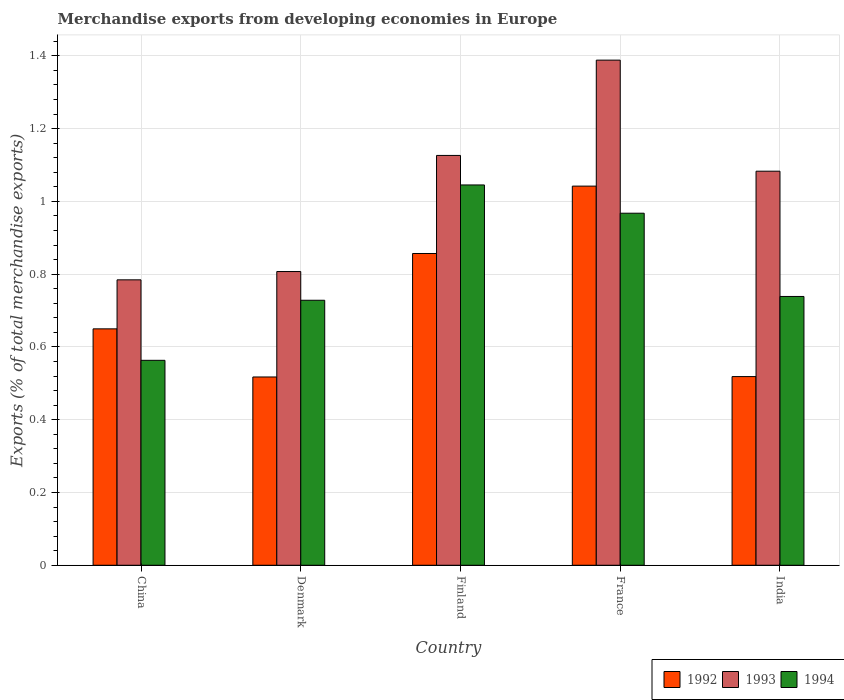How many different coloured bars are there?
Make the answer very short. 3. How many groups of bars are there?
Ensure brevity in your answer.  5. What is the percentage of total merchandise exports in 1992 in India?
Provide a short and direct response. 0.52. Across all countries, what is the maximum percentage of total merchandise exports in 1994?
Your answer should be compact. 1.05. Across all countries, what is the minimum percentage of total merchandise exports in 1993?
Keep it short and to the point. 0.78. In which country was the percentage of total merchandise exports in 1994 maximum?
Provide a succinct answer. Finland. What is the total percentage of total merchandise exports in 1993 in the graph?
Make the answer very short. 5.19. What is the difference between the percentage of total merchandise exports in 1994 in China and that in France?
Make the answer very short. -0.4. What is the difference between the percentage of total merchandise exports in 1992 in China and the percentage of total merchandise exports in 1993 in India?
Provide a succinct answer. -0.43. What is the average percentage of total merchandise exports in 1992 per country?
Your answer should be compact. 0.72. What is the difference between the percentage of total merchandise exports of/in 1994 and percentage of total merchandise exports of/in 1992 in India?
Give a very brief answer. 0.22. In how many countries, is the percentage of total merchandise exports in 1994 greater than 1.2400000000000002 %?
Your response must be concise. 0. What is the ratio of the percentage of total merchandise exports in 1994 in Denmark to that in France?
Keep it short and to the point. 0.75. What is the difference between the highest and the second highest percentage of total merchandise exports in 1992?
Keep it short and to the point. -0.19. What is the difference between the highest and the lowest percentage of total merchandise exports in 1992?
Offer a very short reply. 0.52. Is the sum of the percentage of total merchandise exports in 1993 in Denmark and Finland greater than the maximum percentage of total merchandise exports in 1994 across all countries?
Your answer should be compact. Yes. What does the 2nd bar from the right in France represents?
Provide a short and direct response. 1993. Are all the bars in the graph horizontal?
Your answer should be compact. No. Are the values on the major ticks of Y-axis written in scientific E-notation?
Your answer should be very brief. No. Does the graph contain any zero values?
Make the answer very short. No. Does the graph contain grids?
Your response must be concise. Yes. How many legend labels are there?
Your answer should be very brief. 3. What is the title of the graph?
Ensure brevity in your answer.  Merchandise exports from developing economies in Europe. What is the label or title of the Y-axis?
Make the answer very short. Exports (% of total merchandise exports). What is the Exports (% of total merchandise exports) in 1992 in China?
Ensure brevity in your answer.  0.65. What is the Exports (% of total merchandise exports) of 1993 in China?
Offer a terse response. 0.78. What is the Exports (% of total merchandise exports) of 1994 in China?
Give a very brief answer. 0.56. What is the Exports (% of total merchandise exports) in 1992 in Denmark?
Ensure brevity in your answer.  0.52. What is the Exports (% of total merchandise exports) of 1993 in Denmark?
Offer a very short reply. 0.81. What is the Exports (% of total merchandise exports) of 1994 in Denmark?
Ensure brevity in your answer.  0.73. What is the Exports (% of total merchandise exports) in 1992 in Finland?
Your answer should be very brief. 0.86. What is the Exports (% of total merchandise exports) in 1993 in Finland?
Make the answer very short. 1.13. What is the Exports (% of total merchandise exports) in 1994 in Finland?
Your answer should be very brief. 1.05. What is the Exports (% of total merchandise exports) of 1992 in France?
Make the answer very short. 1.04. What is the Exports (% of total merchandise exports) of 1993 in France?
Keep it short and to the point. 1.39. What is the Exports (% of total merchandise exports) of 1994 in France?
Give a very brief answer. 0.97. What is the Exports (% of total merchandise exports) of 1992 in India?
Give a very brief answer. 0.52. What is the Exports (% of total merchandise exports) of 1993 in India?
Make the answer very short. 1.08. What is the Exports (% of total merchandise exports) of 1994 in India?
Your answer should be compact. 0.74. Across all countries, what is the maximum Exports (% of total merchandise exports) in 1992?
Ensure brevity in your answer.  1.04. Across all countries, what is the maximum Exports (% of total merchandise exports) of 1993?
Ensure brevity in your answer.  1.39. Across all countries, what is the maximum Exports (% of total merchandise exports) in 1994?
Offer a terse response. 1.05. Across all countries, what is the minimum Exports (% of total merchandise exports) of 1992?
Keep it short and to the point. 0.52. Across all countries, what is the minimum Exports (% of total merchandise exports) of 1993?
Offer a very short reply. 0.78. Across all countries, what is the minimum Exports (% of total merchandise exports) in 1994?
Offer a terse response. 0.56. What is the total Exports (% of total merchandise exports) in 1992 in the graph?
Your answer should be very brief. 3.58. What is the total Exports (% of total merchandise exports) in 1993 in the graph?
Your answer should be very brief. 5.19. What is the total Exports (% of total merchandise exports) of 1994 in the graph?
Make the answer very short. 4.04. What is the difference between the Exports (% of total merchandise exports) of 1992 in China and that in Denmark?
Provide a succinct answer. 0.13. What is the difference between the Exports (% of total merchandise exports) of 1993 in China and that in Denmark?
Your response must be concise. -0.02. What is the difference between the Exports (% of total merchandise exports) of 1994 in China and that in Denmark?
Provide a succinct answer. -0.17. What is the difference between the Exports (% of total merchandise exports) of 1992 in China and that in Finland?
Provide a succinct answer. -0.21. What is the difference between the Exports (% of total merchandise exports) in 1993 in China and that in Finland?
Ensure brevity in your answer.  -0.34. What is the difference between the Exports (% of total merchandise exports) of 1994 in China and that in Finland?
Make the answer very short. -0.48. What is the difference between the Exports (% of total merchandise exports) in 1992 in China and that in France?
Your response must be concise. -0.39. What is the difference between the Exports (% of total merchandise exports) of 1993 in China and that in France?
Your response must be concise. -0.6. What is the difference between the Exports (% of total merchandise exports) in 1994 in China and that in France?
Offer a terse response. -0.4. What is the difference between the Exports (% of total merchandise exports) in 1992 in China and that in India?
Keep it short and to the point. 0.13. What is the difference between the Exports (% of total merchandise exports) of 1993 in China and that in India?
Provide a succinct answer. -0.3. What is the difference between the Exports (% of total merchandise exports) in 1994 in China and that in India?
Provide a succinct answer. -0.18. What is the difference between the Exports (% of total merchandise exports) of 1992 in Denmark and that in Finland?
Offer a terse response. -0.34. What is the difference between the Exports (% of total merchandise exports) in 1993 in Denmark and that in Finland?
Your answer should be compact. -0.32. What is the difference between the Exports (% of total merchandise exports) in 1994 in Denmark and that in Finland?
Your response must be concise. -0.32. What is the difference between the Exports (% of total merchandise exports) in 1992 in Denmark and that in France?
Offer a terse response. -0.52. What is the difference between the Exports (% of total merchandise exports) in 1993 in Denmark and that in France?
Ensure brevity in your answer.  -0.58. What is the difference between the Exports (% of total merchandise exports) in 1994 in Denmark and that in France?
Offer a terse response. -0.24. What is the difference between the Exports (% of total merchandise exports) in 1992 in Denmark and that in India?
Provide a succinct answer. -0. What is the difference between the Exports (% of total merchandise exports) in 1993 in Denmark and that in India?
Offer a terse response. -0.28. What is the difference between the Exports (% of total merchandise exports) of 1994 in Denmark and that in India?
Make the answer very short. -0.01. What is the difference between the Exports (% of total merchandise exports) in 1992 in Finland and that in France?
Your response must be concise. -0.19. What is the difference between the Exports (% of total merchandise exports) of 1993 in Finland and that in France?
Your answer should be very brief. -0.26. What is the difference between the Exports (% of total merchandise exports) in 1994 in Finland and that in France?
Make the answer very short. 0.08. What is the difference between the Exports (% of total merchandise exports) of 1992 in Finland and that in India?
Your answer should be compact. 0.34. What is the difference between the Exports (% of total merchandise exports) in 1993 in Finland and that in India?
Provide a succinct answer. 0.04. What is the difference between the Exports (% of total merchandise exports) in 1994 in Finland and that in India?
Give a very brief answer. 0.31. What is the difference between the Exports (% of total merchandise exports) of 1992 in France and that in India?
Your answer should be very brief. 0.52. What is the difference between the Exports (% of total merchandise exports) in 1993 in France and that in India?
Offer a very short reply. 0.31. What is the difference between the Exports (% of total merchandise exports) of 1994 in France and that in India?
Your answer should be very brief. 0.23. What is the difference between the Exports (% of total merchandise exports) of 1992 in China and the Exports (% of total merchandise exports) of 1993 in Denmark?
Provide a succinct answer. -0.16. What is the difference between the Exports (% of total merchandise exports) in 1992 in China and the Exports (% of total merchandise exports) in 1994 in Denmark?
Offer a terse response. -0.08. What is the difference between the Exports (% of total merchandise exports) in 1993 in China and the Exports (% of total merchandise exports) in 1994 in Denmark?
Your response must be concise. 0.06. What is the difference between the Exports (% of total merchandise exports) of 1992 in China and the Exports (% of total merchandise exports) of 1993 in Finland?
Your response must be concise. -0.48. What is the difference between the Exports (% of total merchandise exports) in 1992 in China and the Exports (% of total merchandise exports) in 1994 in Finland?
Offer a terse response. -0.4. What is the difference between the Exports (% of total merchandise exports) of 1993 in China and the Exports (% of total merchandise exports) of 1994 in Finland?
Provide a succinct answer. -0.26. What is the difference between the Exports (% of total merchandise exports) in 1992 in China and the Exports (% of total merchandise exports) in 1993 in France?
Keep it short and to the point. -0.74. What is the difference between the Exports (% of total merchandise exports) in 1992 in China and the Exports (% of total merchandise exports) in 1994 in France?
Offer a very short reply. -0.32. What is the difference between the Exports (% of total merchandise exports) of 1993 in China and the Exports (% of total merchandise exports) of 1994 in France?
Provide a short and direct response. -0.18. What is the difference between the Exports (% of total merchandise exports) of 1992 in China and the Exports (% of total merchandise exports) of 1993 in India?
Your answer should be very brief. -0.43. What is the difference between the Exports (% of total merchandise exports) in 1992 in China and the Exports (% of total merchandise exports) in 1994 in India?
Your response must be concise. -0.09. What is the difference between the Exports (% of total merchandise exports) of 1993 in China and the Exports (% of total merchandise exports) of 1994 in India?
Give a very brief answer. 0.05. What is the difference between the Exports (% of total merchandise exports) of 1992 in Denmark and the Exports (% of total merchandise exports) of 1993 in Finland?
Ensure brevity in your answer.  -0.61. What is the difference between the Exports (% of total merchandise exports) in 1992 in Denmark and the Exports (% of total merchandise exports) in 1994 in Finland?
Make the answer very short. -0.53. What is the difference between the Exports (% of total merchandise exports) of 1993 in Denmark and the Exports (% of total merchandise exports) of 1994 in Finland?
Give a very brief answer. -0.24. What is the difference between the Exports (% of total merchandise exports) of 1992 in Denmark and the Exports (% of total merchandise exports) of 1993 in France?
Make the answer very short. -0.87. What is the difference between the Exports (% of total merchandise exports) of 1992 in Denmark and the Exports (% of total merchandise exports) of 1994 in France?
Your answer should be very brief. -0.45. What is the difference between the Exports (% of total merchandise exports) of 1993 in Denmark and the Exports (% of total merchandise exports) of 1994 in France?
Your answer should be very brief. -0.16. What is the difference between the Exports (% of total merchandise exports) of 1992 in Denmark and the Exports (% of total merchandise exports) of 1993 in India?
Ensure brevity in your answer.  -0.57. What is the difference between the Exports (% of total merchandise exports) in 1992 in Denmark and the Exports (% of total merchandise exports) in 1994 in India?
Keep it short and to the point. -0.22. What is the difference between the Exports (% of total merchandise exports) in 1993 in Denmark and the Exports (% of total merchandise exports) in 1994 in India?
Provide a succinct answer. 0.07. What is the difference between the Exports (% of total merchandise exports) in 1992 in Finland and the Exports (% of total merchandise exports) in 1993 in France?
Keep it short and to the point. -0.53. What is the difference between the Exports (% of total merchandise exports) of 1992 in Finland and the Exports (% of total merchandise exports) of 1994 in France?
Ensure brevity in your answer.  -0.11. What is the difference between the Exports (% of total merchandise exports) in 1993 in Finland and the Exports (% of total merchandise exports) in 1994 in France?
Your response must be concise. 0.16. What is the difference between the Exports (% of total merchandise exports) of 1992 in Finland and the Exports (% of total merchandise exports) of 1993 in India?
Provide a succinct answer. -0.23. What is the difference between the Exports (% of total merchandise exports) of 1992 in Finland and the Exports (% of total merchandise exports) of 1994 in India?
Make the answer very short. 0.12. What is the difference between the Exports (% of total merchandise exports) of 1993 in Finland and the Exports (% of total merchandise exports) of 1994 in India?
Give a very brief answer. 0.39. What is the difference between the Exports (% of total merchandise exports) of 1992 in France and the Exports (% of total merchandise exports) of 1993 in India?
Your answer should be compact. -0.04. What is the difference between the Exports (% of total merchandise exports) in 1992 in France and the Exports (% of total merchandise exports) in 1994 in India?
Ensure brevity in your answer.  0.3. What is the difference between the Exports (% of total merchandise exports) in 1993 in France and the Exports (% of total merchandise exports) in 1994 in India?
Provide a short and direct response. 0.65. What is the average Exports (% of total merchandise exports) in 1992 per country?
Keep it short and to the point. 0.72. What is the average Exports (% of total merchandise exports) of 1993 per country?
Make the answer very short. 1.04. What is the average Exports (% of total merchandise exports) in 1994 per country?
Offer a terse response. 0.81. What is the difference between the Exports (% of total merchandise exports) in 1992 and Exports (% of total merchandise exports) in 1993 in China?
Ensure brevity in your answer.  -0.13. What is the difference between the Exports (% of total merchandise exports) in 1992 and Exports (% of total merchandise exports) in 1994 in China?
Offer a very short reply. 0.09. What is the difference between the Exports (% of total merchandise exports) in 1993 and Exports (% of total merchandise exports) in 1994 in China?
Your answer should be compact. 0.22. What is the difference between the Exports (% of total merchandise exports) in 1992 and Exports (% of total merchandise exports) in 1993 in Denmark?
Ensure brevity in your answer.  -0.29. What is the difference between the Exports (% of total merchandise exports) of 1992 and Exports (% of total merchandise exports) of 1994 in Denmark?
Provide a succinct answer. -0.21. What is the difference between the Exports (% of total merchandise exports) in 1993 and Exports (% of total merchandise exports) in 1994 in Denmark?
Your response must be concise. 0.08. What is the difference between the Exports (% of total merchandise exports) in 1992 and Exports (% of total merchandise exports) in 1993 in Finland?
Your answer should be very brief. -0.27. What is the difference between the Exports (% of total merchandise exports) in 1992 and Exports (% of total merchandise exports) in 1994 in Finland?
Your answer should be very brief. -0.19. What is the difference between the Exports (% of total merchandise exports) of 1993 and Exports (% of total merchandise exports) of 1994 in Finland?
Offer a very short reply. 0.08. What is the difference between the Exports (% of total merchandise exports) in 1992 and Exports (% of total merchandise exports) in 1993 in France?
Keep it short and to the point. -0.35. What is the difference between the Exports (% of total merchandise exports) of 1992 and Exports (% of total merchandise exports) of 1994 in France?
Provide a short and direct response. 0.07. What is the difference between the Exports (% of total merchandise exports) in 1993 and Exports (% of total merchandise exports) in 1994 in France?
Keep it short and to the point. 0.42. What is the difference between the Exports (% of total merchandise exports) of 1992 and Exports (% of total merchandise exports) of 1993 in India?
Provide a short and direct response. -0.56. What is the difference between the Exports (% of total merchandise exports) in 1992 and Exports (% of total merchandise exports) in 1994 in India?
Give a very brief answer. -0.22. What is the difference between the Exports (% of total merchandise exports) of 1993 and Exports (% of total merchandise exports) of 1994 in India?
Make the answer very short. 0.34. What is the ratio of the Exports (% of total merchandise exports) of 1992 in China to that in Denmark?
Make the answer very short. 1.26. What is the ratio of the Exports (% of total merchandise exports) in 1993 in China to that in Denmark?
Offer a terse response. 0.97. What is the ratio of the Exports (% of total merchandise exports) in 1994 in China to that in Denmark?
Your answer should be compact. 0.77. What is the ratio of the Exports (% of total merchandise exports) of 1992 in China to that in Finland?
Your answer should be compact. 0.76. What is the ratio of the Exports (% of total merchandise exports) of 1993 in China to that in Finland?
Provide a succinct answer. 0.7. What is the ratio of the Exports (% of total merchandise exports) in 1994 in China to that in Finland?
Make the answer very short. 0.54. What is the ratio of the Exports (% of total merchandise exports) of 1992 in China to that in France?
Ensure brevity in your answer.  0.62. What is the ratio of the Exports (% of total merchandise exports) in 1993 in China to that in France?
Provide a succinct answer. 0.57. What is the ratio of the Exports (% of total merchandise exports) of 1994 in China to that in France?
Provide a succinct answer. 0.58. What is the ratio of the Exports (% of total merchandise exports) of 1992 in China to that in India?
Offer a very short reply. 1.25. What is the ratio of the Exports (% of total merchandise exports) in 1993 in China to that in India?
Make the answer very short. 0.72. What is the ratio of the Exports (% of total merchandise exports) in 1994 in China to that in India?
Ensure brevity in your answer.  0.76. What is the ratio of the Exports (% of total merchandise exports) of 1992 in Denmark to that in Finland?
Your answer should be very brief. 0.6. What is the ratio of the Exports (% of total merchandise exports) of 1993 in Denmark to that in Finland?
Your answer should be compact. 0.72. What is the ratio of the Exports (% of total merchandise exports) in 1994 in Denmark to that in Finland?
Offer a very short reply. 0.7. What is the ratio of the Exports (% of total merchandise exports) in 1992 in Denmark to that in France?
Keep it short and to the point. 0.5. What is the ratio of the Exports (% of total merchandise exports) in 1993 in Denmark to that in France?
Keep it short and to the point. 0.58. What is the ratio of the Exports (% of total merchandise exports) in 1994 in Denmark to that in France?
Give a very brief answer. 0.75. What is the ratio of the Exports (% of total merchandise exports) of 1993 in Denmark to that in India?
Offer a terse response. 0.75. What is the ratio of the Exports (% of total merchandise exports) in 1994 in Denmark to that in India?
Ensure brevity in your answer.  0.99. What is the ratio of the Exports (% of total merchandise exports) in 1992 in Finland to that in France?
Keep it short and to the point. 0.82. What is the ratio of the Exports (% of total merchandise exports) in 1993 in Finland to that in France?
Provide a succinct answer. 0.81. What is the ratio of the Exports (% of total merchandise exports) of 1994 in Finland to that in France?
Make the answer very short. 1.08. What is the ratio of the Exports (% of total merchandise exports) in 1992 in Finland to that in India?
Give a very brief answer. 1.65. What is the ratio of the Exports (% of total merchandise exports) in 1994 in Finland to that in India?
Keep it short and to the point. 1.41. What is the ratio of the Exports (% of total merchandise exports) in 1992 in France to that in India?
Provide a succinct answer. 2.01. What is the ratio of the Exports (% of total merchandise exports) in 1993 in France to that in India?
Give a very brief answer. 1.28. What is the ratio of the Exports (% of total merchandise exports) in 1994 in France to that in India?
Your response must be concise. 1.31. What is the difference between the highest and the second highest Exports (% of total merchandise exports) of 1992?
Offer a terse response. 0.19. What is the difference between the highest and the second highest Exports (% of total merchandise exports) in 1993?
Provide a succinct answer. 0.26. What is the difference between the highest and the second highest Exports (% of total merchandise exports) in 1994?
Make the answer very short. 0.08. What is the difference between the highest and the lowest Exports (% of total merchandise exports) in 1992?
Your answer should be very brief. 0.52. What is the difference between the highest and the lowest Exports (% of total merchandise exports) of 1993?
Offer a very short reply. 0.6. What is the difference between the highest and the lowest Exports (% of total merchandise exports) of 1994?
Ensure brevity in your answer.  0.48. 